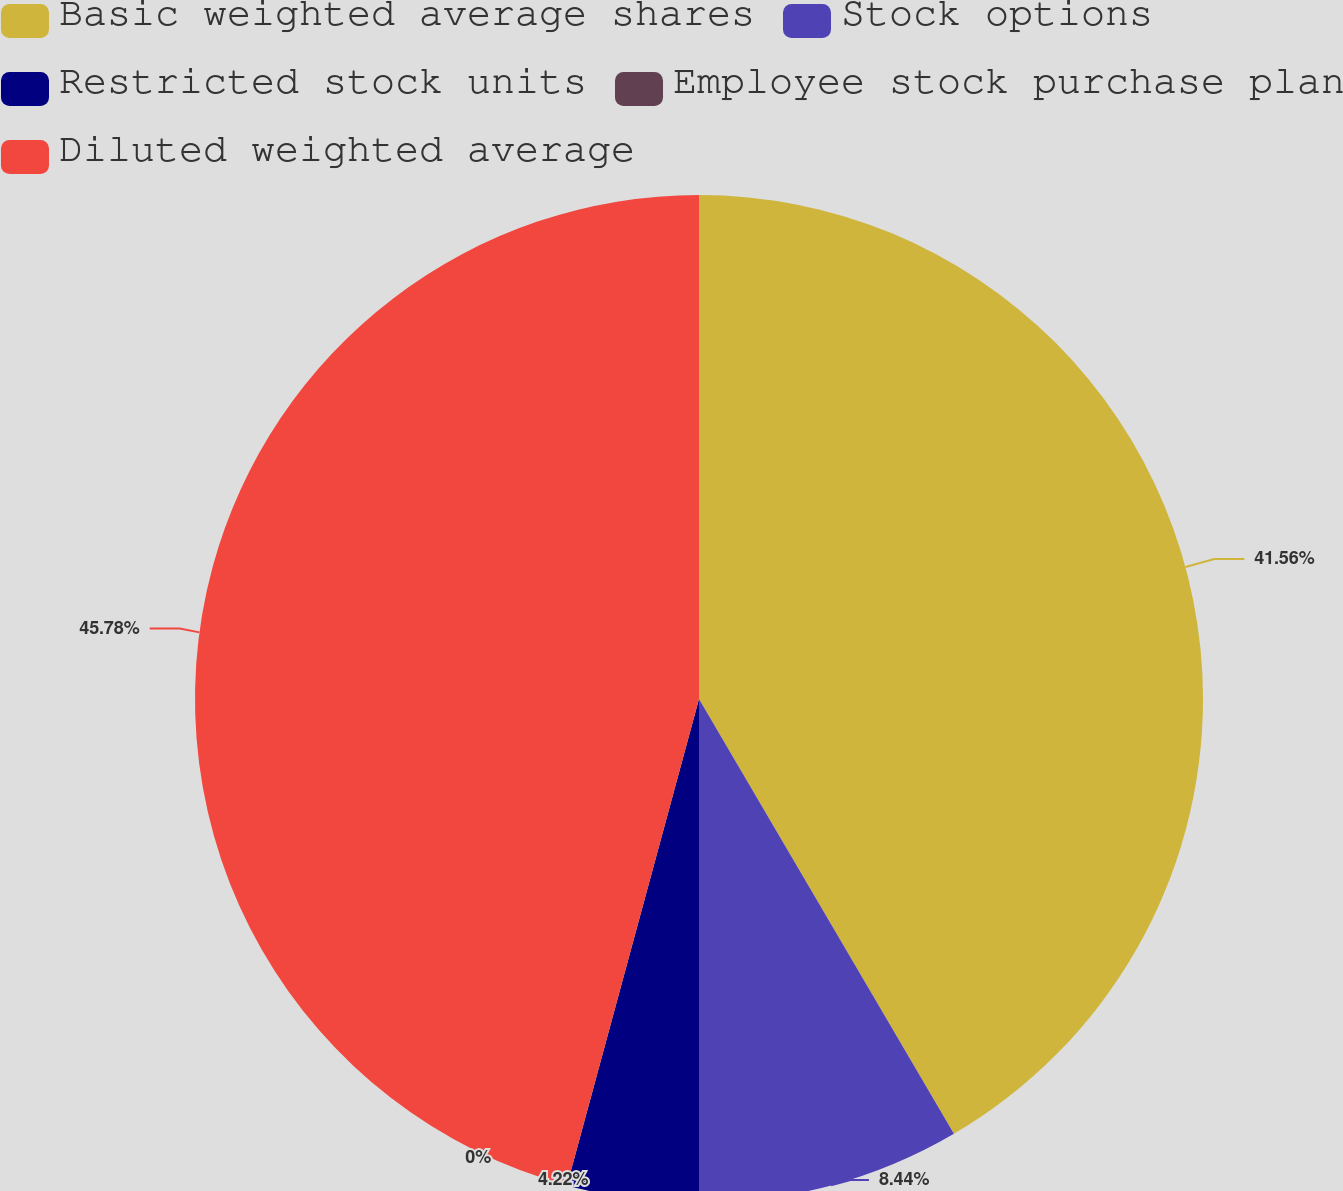<chart> <loc_0><loc_0><loc_500><loc_500><pie_chart><fcel>Basic weighted average shares<fcel>Stock options<fcel>Restricted stock units<fcel>Employee stock purchase plan<fcel>Diluted weighted average<nl><fcel>41.56%<fcel>8.44%<fcel>4.22%<fcel>0.0%<fcel>45.78%<nl></chart> 